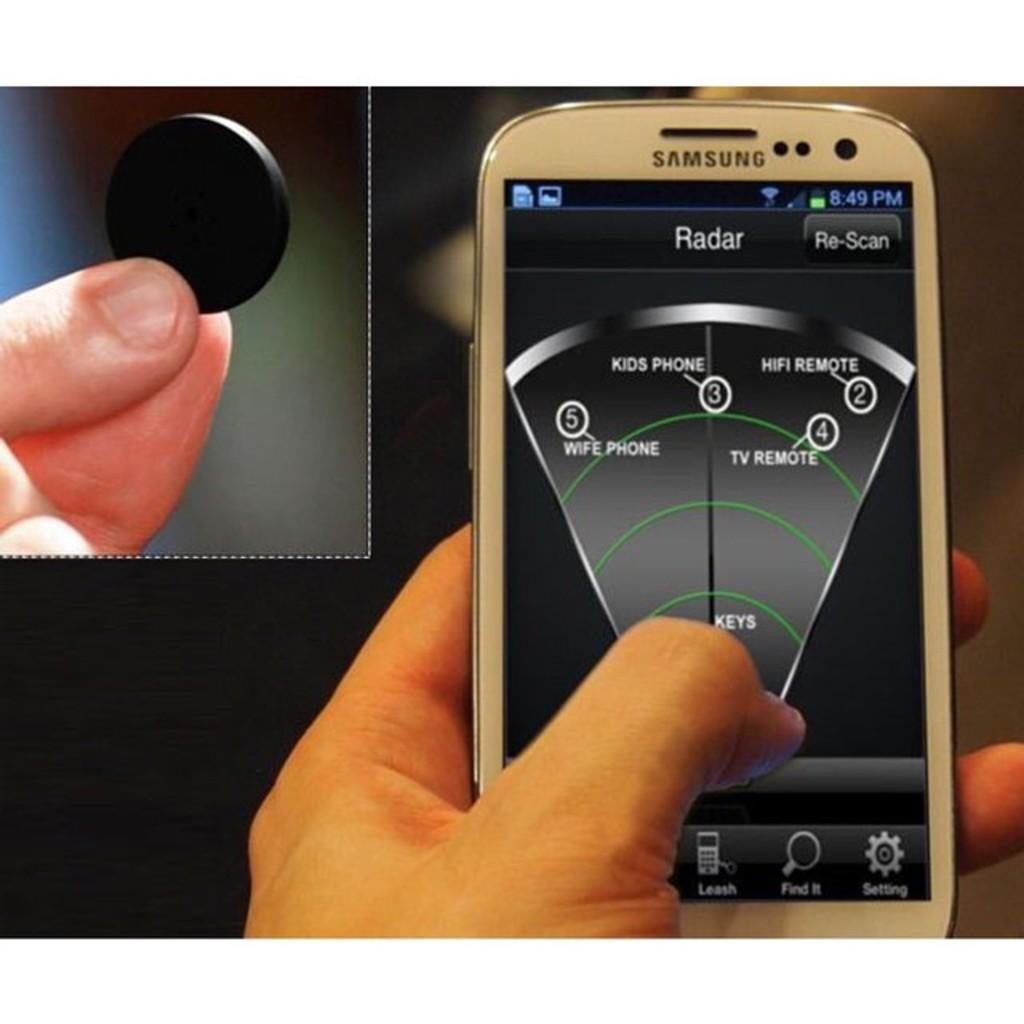What is the person on the left side of the image holding? The person on the left side of the image is holding a mobile. What is the person on the right side of the image holding? The person on the right side of the image is holding a coin. What color is the daughter's shirt in the image? There is no daughter present in the image, so we cannot answer a question about her shirt. 